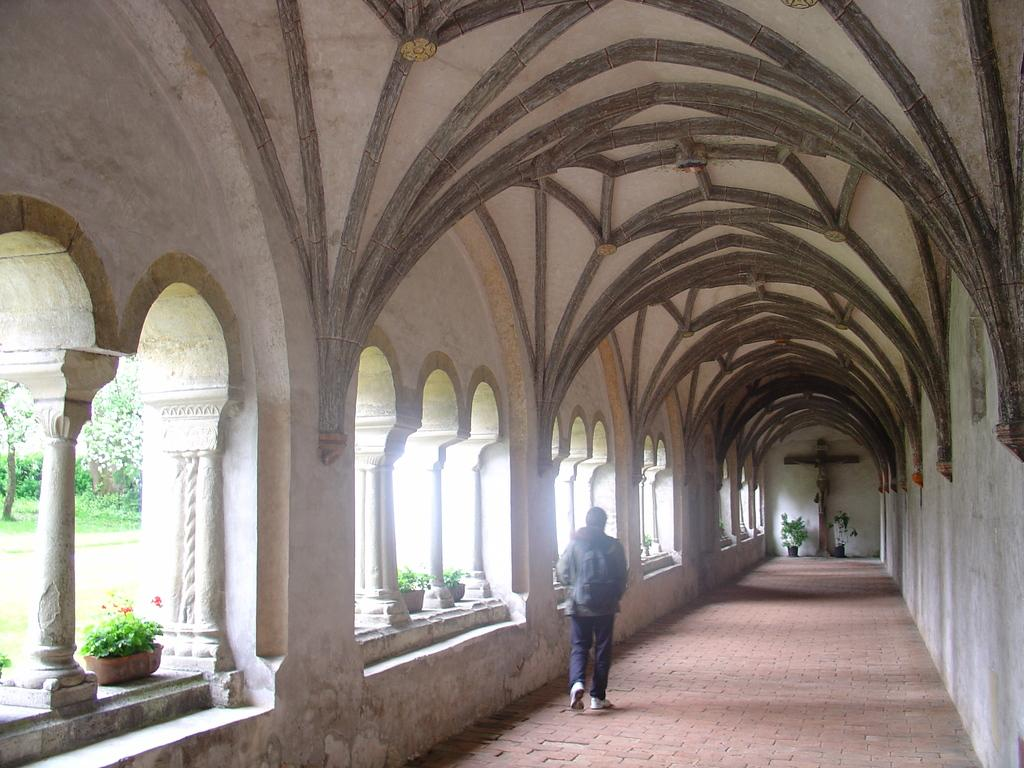What is the main subject of the image? There is a person in the image. What is the person wearing? The person is wearing a bag. What is the person doing in the image? The person is walking on the floor. What architectural features can be seen in the image? There are pillars in the image. What type of vegetation is present in the image? There are potted plants, grass, and trees in the image. What symbol can be seen on a wall in the image? There is a cross symbol on a wall in the image. What type of store can be seen in the image? There is no store present in the image. What color is the silver in the image? There is no silver present in the image. 